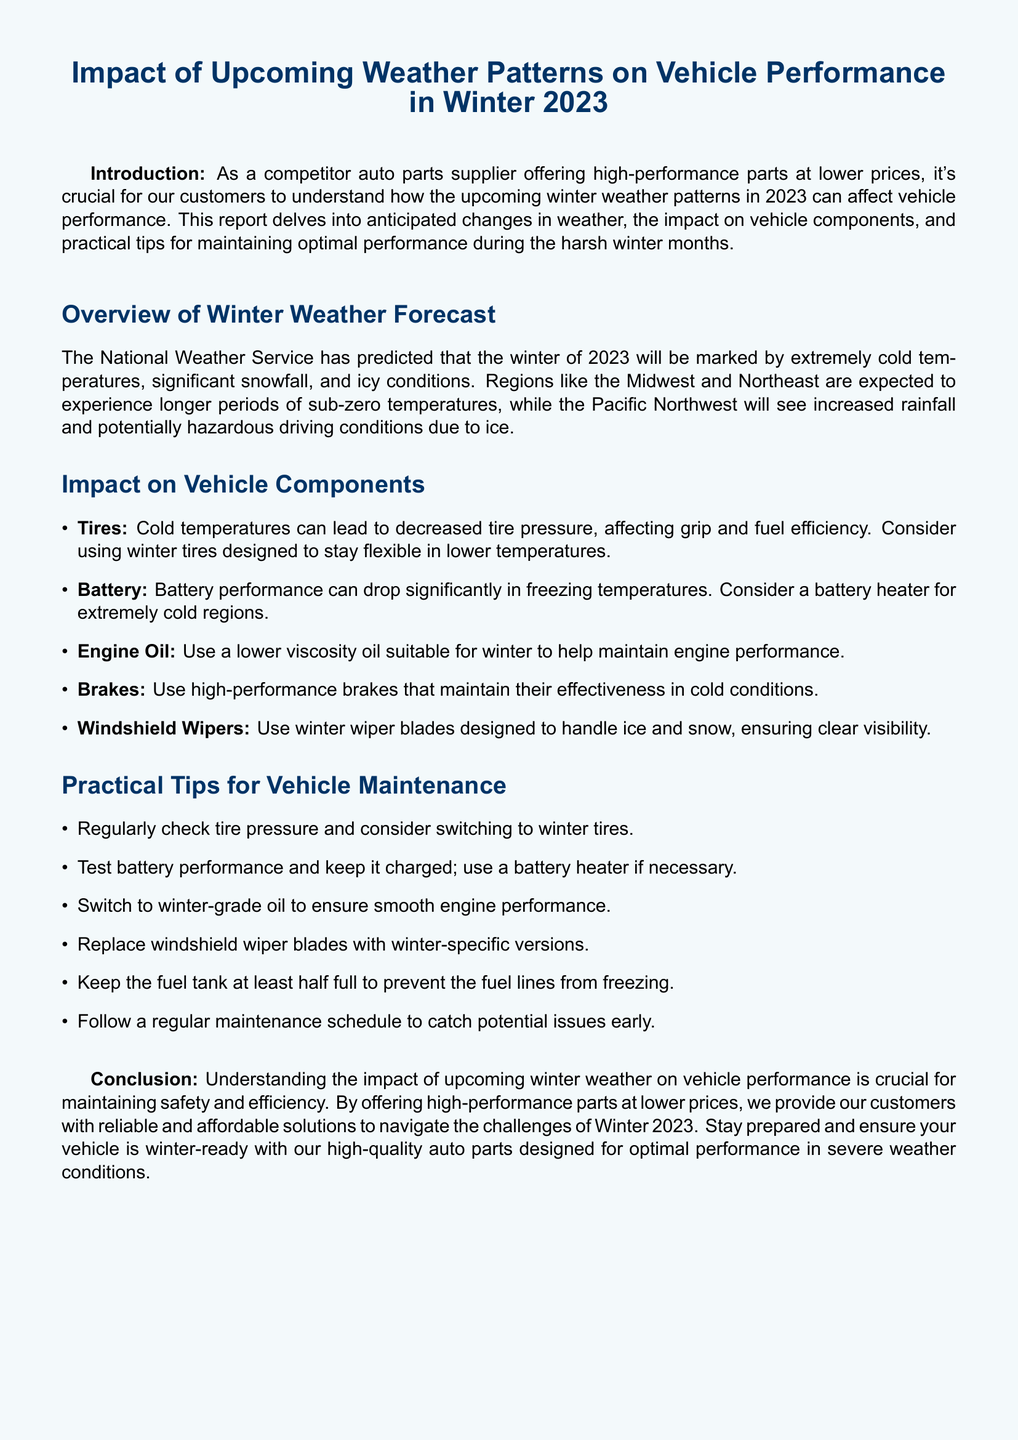What is the predicted temperature condition for winter 2023? The document states that extremely cold temperatures are predicted.
Answer: extremely cold temperatures Which regions are expected to experience sub-zero temperatures? The document mentions the Midwest and Northeast as regions with longer sub-zero temperatures.
Answer: Midwest and Northeast What is the recommended tire type for winter conditions? The document suggests using winter tires designed to stay flexible in lower temperatures.
Answer: winter tires What type of oil should be used during winter? The document recommends using a lower viscosity oil suitable for winter.
Answer: lower viscosity oil What should be checked regularly for vehicle maintenance? The document advises regularly checking tire pressure.
Answer: tire pressure How can battery performance be improved in freezing temperatures? The document suggests using a battery heater in extremely cold regions.
Answer: battery heater What practical tip is provided for preventing fuel line freezing? The document states to keep the fuel tank at least half full.
Answer: half full What is the main goal of this report? The document's main goal is to help customers understand the impact of winter weather on vehicle performance.
Answer: understand impact What type of wiper blades should be used for winter? The document recommends using winter-specific wiper blades.
Answer: winter-specific wiper blades 